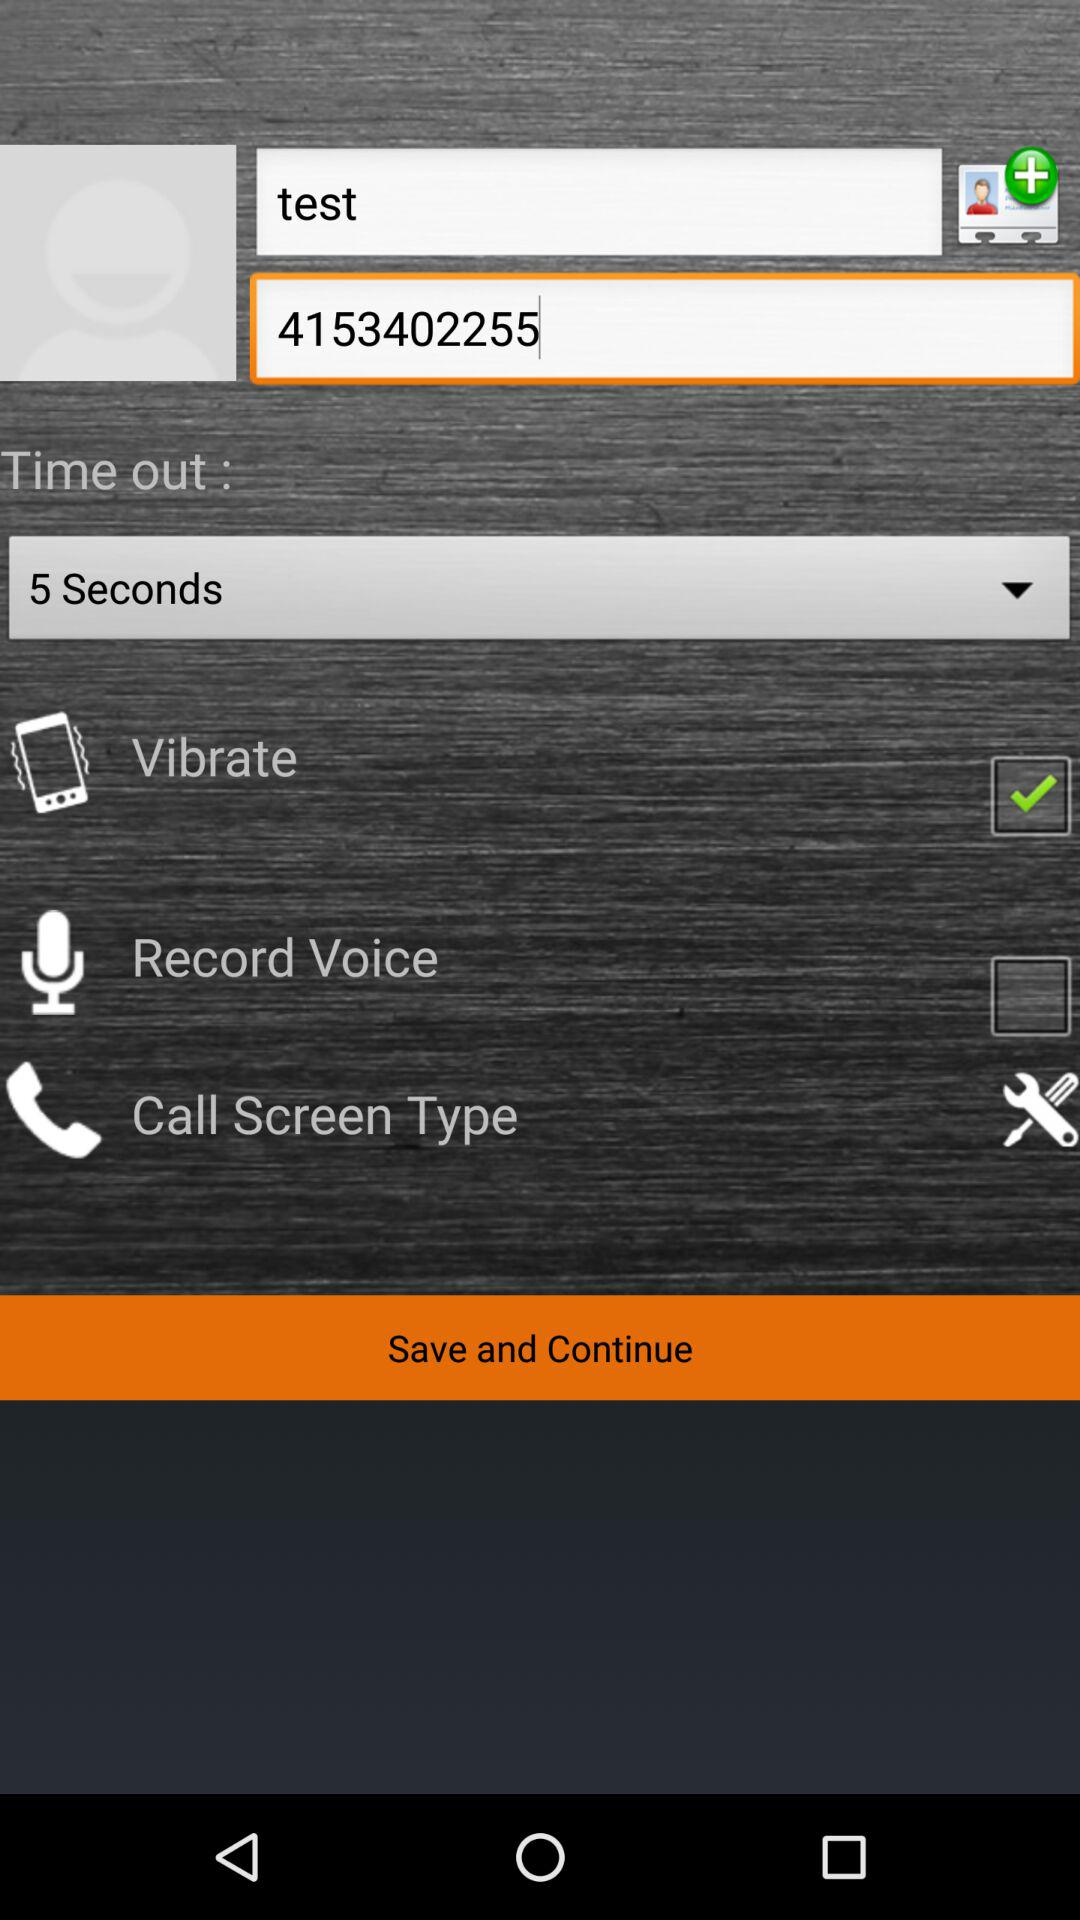What is the number of "test"? The number is 4153402255. 